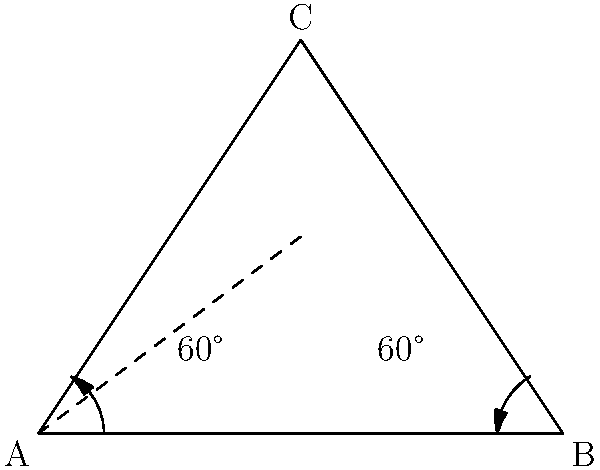In folding an origami unicorn, you need to create a triangle with two 60° angles at its base. If the third angle is at the top point of the triangle, what is its measure? Let's solve this step-by-step:

1. Remember that the sum of angles in a triangle is always 180°.

2. We know that there are two 60° angles at the base of the triangle.

3. Let's call the unknown angle at the top $x$.

4. We can write an equation:
   $60° + 60° + x = 180°$

5. Simplify:
   $120° + x = 180°$

6. Subtract 120° from both sides:
   $x = 180° - 120°$

7. Solve:
   $x = 60°$

Therefore, the angle at the top of the triangle is also 60°.
Answer: 60° 